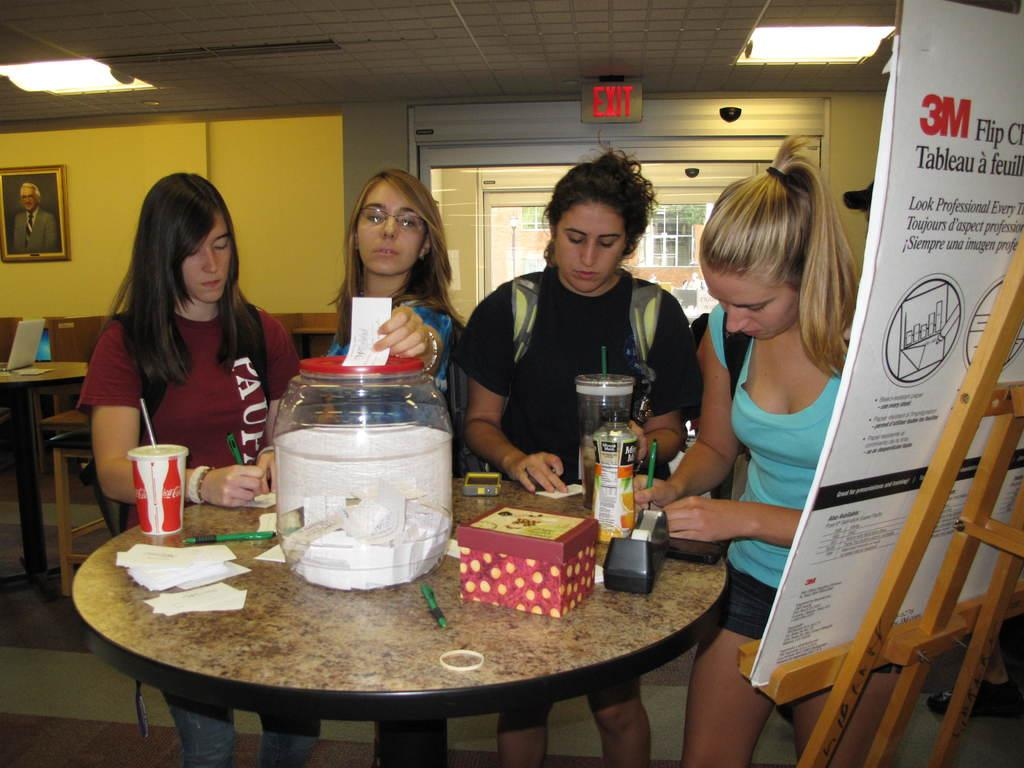What can be seen in the image? There are women standing in the image. What objects are on the table? There is a jar, a bottle, and glasses on the table. Is there anything on the wall in the background? Yes, there is a frame on the wall in the background. What type of business is being conducted in the image? There is no indication of a business being conducted in the image. Can you see the sea in the image? No, the sea is not visible in the image. 